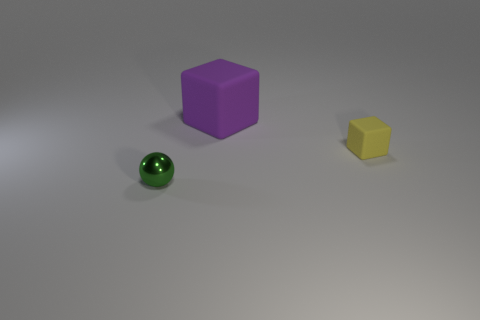Are there more tiny objects that are on the right side of the small green metal object than large blocks that are to the right of the small rubber thing?
Offer a terse response. Yes. What is the material of the other object that is the same size as the green metal thing?
Provide a succinct answer. Rubber. How many objects are either big purple objects or objects behind the small yellow matte object?
Ensure brevity in your answer.  1. Do the yellow cube and the object that is in front of the tiny cube have the same size?
Provide a short and direct response. Yes. How many spheres are yellow rubber things or small green metal objects?
Keep it short and to the point. 1. How many things are on the right side of the small green shiny thing and in front of the purple cube?
Provide a short and direct response. 1. What number of other things are the same color as the large matte cube?
Give a very brief answer. 0. There is a thing that is on the left side of the large purple rubber block; what shape is it?
Give a very brief answer. Sphere. Do the large purple block and the small yellow block have the same material?
Your answer should be very brief. Yes. Is there anything else that has the same size as the green metallic object?
Your answer should be very brief. Yes. 